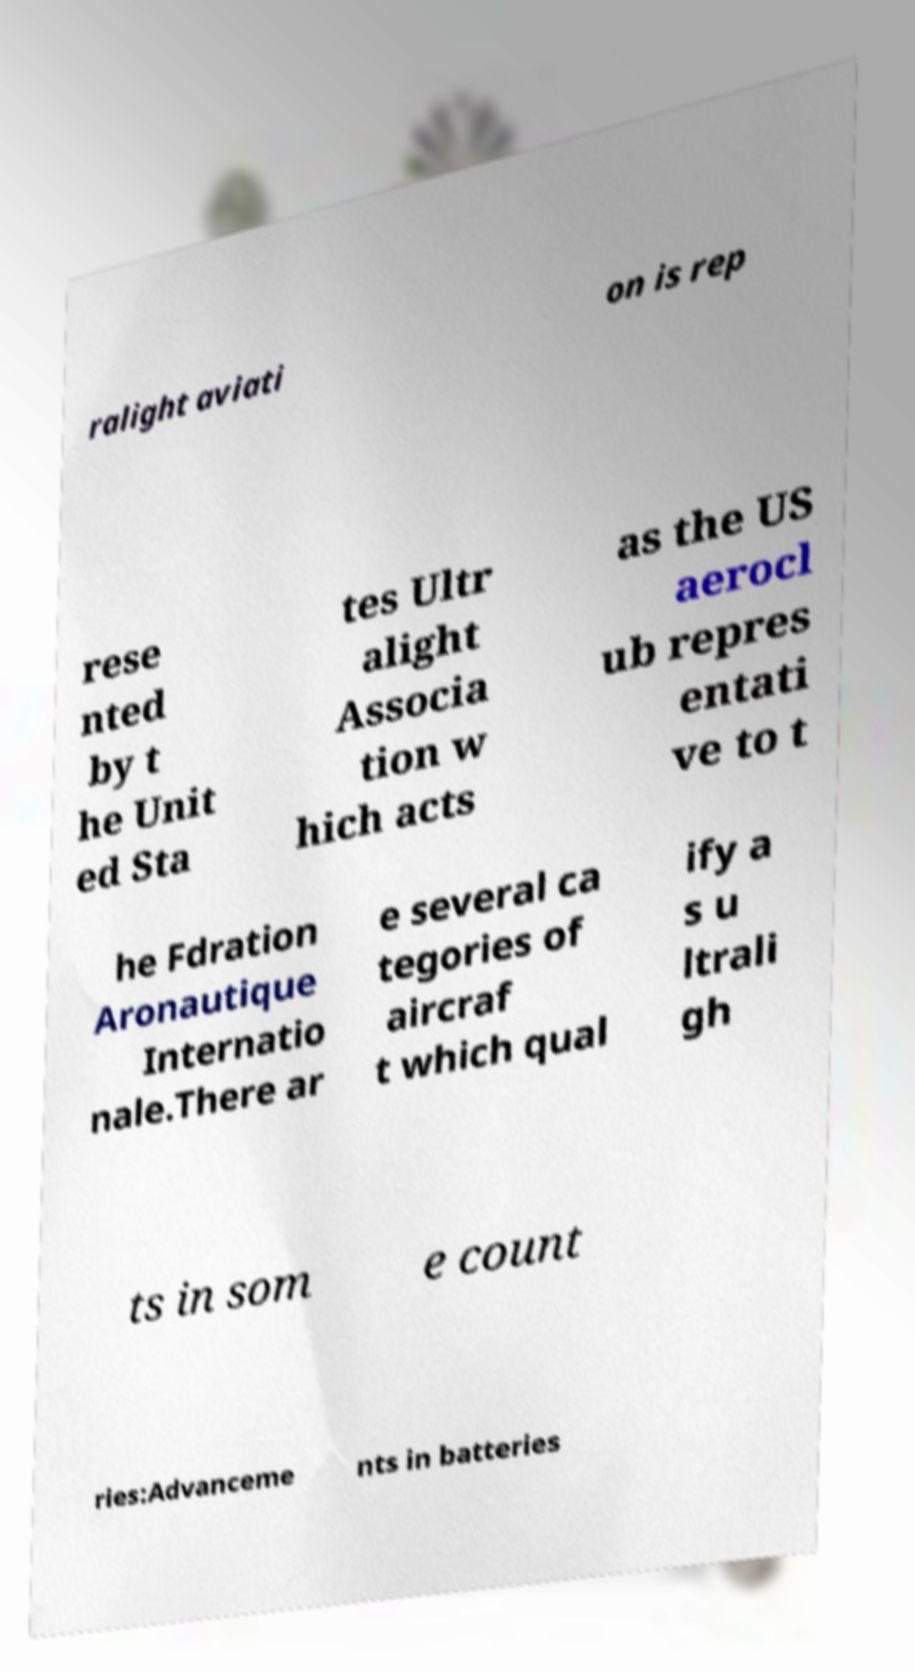Please identify and transcribe the text found in this image. ralight aviati on is rep rese nted by t he Unit ed Sta tes Ultr alight Associa tion w hich acts as the US aerocl ub repres entati ve to t he Fdration Aronautique Internatio nale.There ar e several ca tegories of aircraf t which qual ify a s u ltrali gh ts in som e count ries:Advanceme nts in batteries 